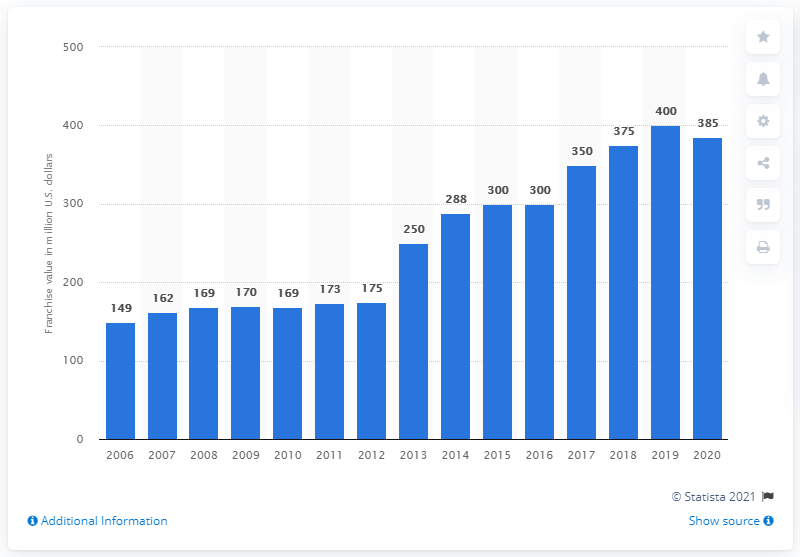Point out several critical features in this image. According to data available in 2020, the Buffalo Sabres franchise was estimated to be worth approximately 385 million dollars. The Buffalo Sabres began playing in the National Hockey League in the year 2006. 